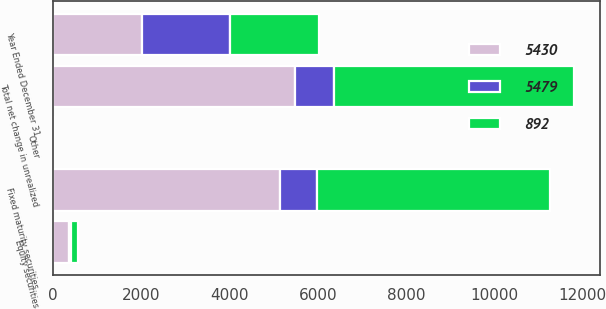<chart> <loc_0><loc_0><loc_500><loc_500><stacked_bar_chart><ecel><fcel>Year Ended December 31<fcel>Fixed maturity securities<fcel>Equity securities<fcel>Other<fcel>Total net change in unrealized<nl><fcel>892<fcel>2009<fcel>5278<fcel>156<fcel>4<fcel>5430<nl><fcel>5430<fcel>2008<fcel>5137<fcel>347<fcel>5<fcel>5479<nl><fcel>5479<fcel>2007<fcel>847<fcel>47<fcel>2<fcel>892<nl></chart> 